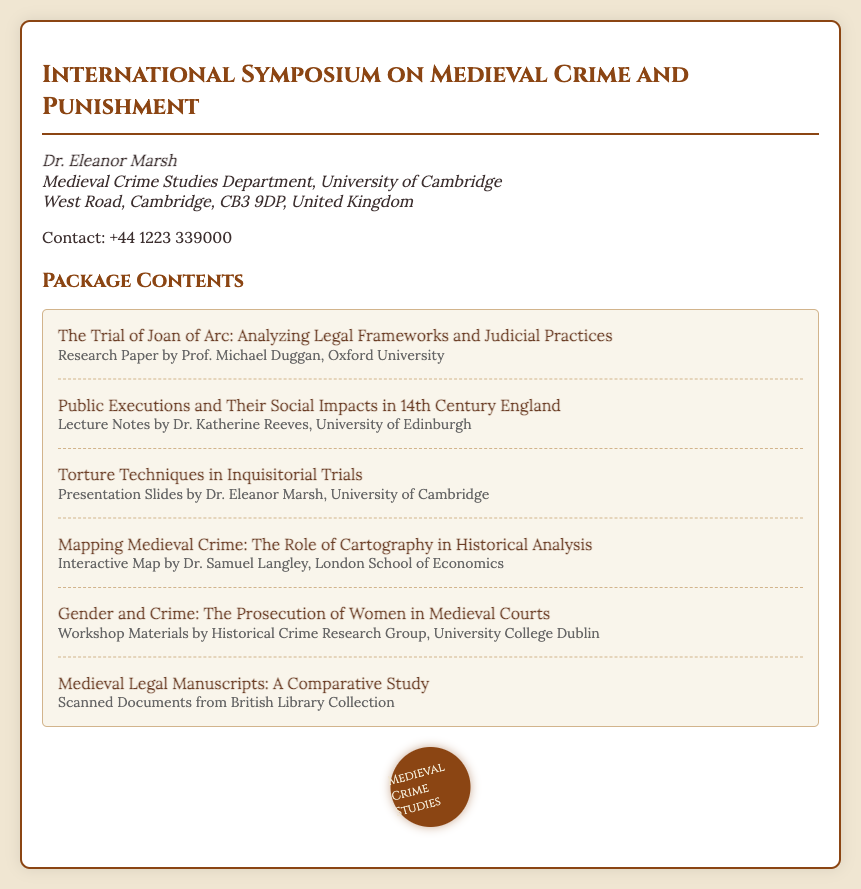What is the title of the conference? The title of the conference is provided in the document as the main heading, which is "International Symposium on Medieval Crime and Punishment."
Answer: International Symposium on Medieval Crime and Punishment Who is the contact person for the conference? The contact person is specified in the document under the contact section, which is Dr. Eleanor Marsh.
Answer: Dr. Eleanor Marsh What university is Dr. Eleanor Marsh associated with? Dr. Eleanor Marsh's association is mentioned in the address, specifically with the Medieval Crime Studies Department, University of Cambridge.
Answer: University of Cambridge How many content items are listed in the package contents? The number of items is counted from the contents section, which lists six different research works.
Answer: 6 Which university is associated with the workshop materials? The workshop materials are specifically attributed to the Historical Crime Research Group, University College Dublin, as mentioned in the content item.
Answer: University College Dublin What type of presentation is included regarding torture techniques? The document categorizes the presentation with the title related to torture techniques as "Presentation Slides," indicating the format of the content.
Answer: Presentation Slides What is the focus of the paper by Prof. Michael Duggan? The title indicates that the focus of the paper is on "The Trial of Joan of Arc: Analyzing Legal Frameworks and Judicial Practices," signaling its thematic concern.
Answer: The Trial of Joan of Arc What item is included from the British Library Collection? The content item specifically mentions "Scanned Documents from British Library Collection," indicating what is included from that source.
Answer: Scanned Documents from British Library Collection What role does cartography play according to Dr. Samuel Langley? The content item specifies "Mapping Medieval Crime: The Role of Cartography in Historical Analysis," indicating the aspect being explored.
Answer: Mapping Medieval Crime 